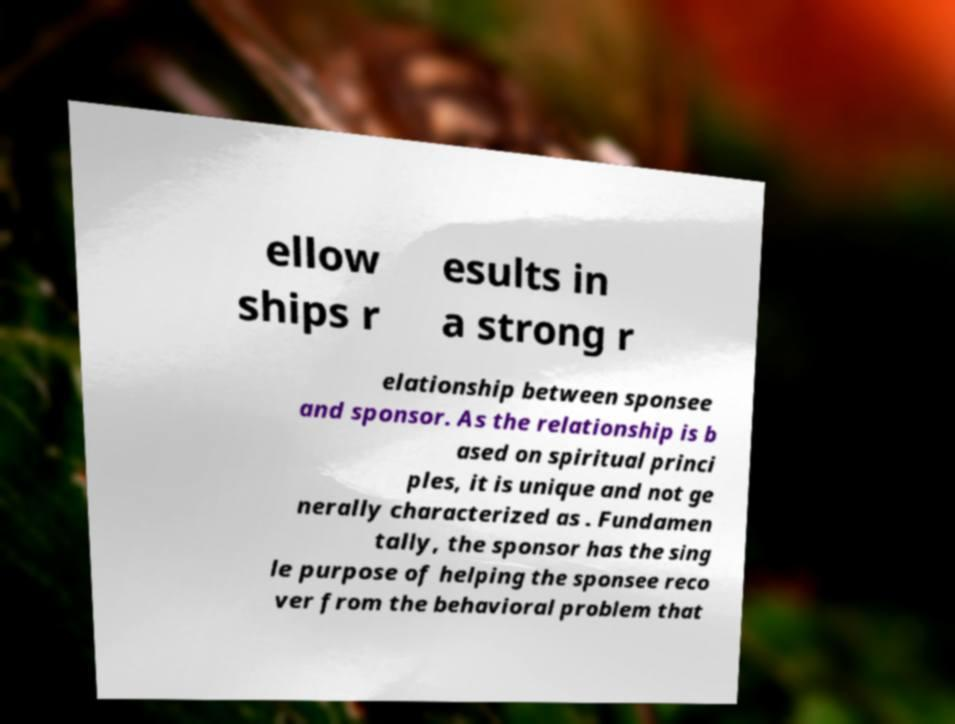For documentation purposes, I need the text within this image transcribed. Could you provide that? ellow ships r esults in a strong r elationship between sponsee and sponsor. As the relationship is b ased on spiritual princi ples, it is unique and not ge nerally characterized as . Fundamen tally, the sponsor has the sing le purpose of helping the sponsee reco ver from the behavioral problem that 